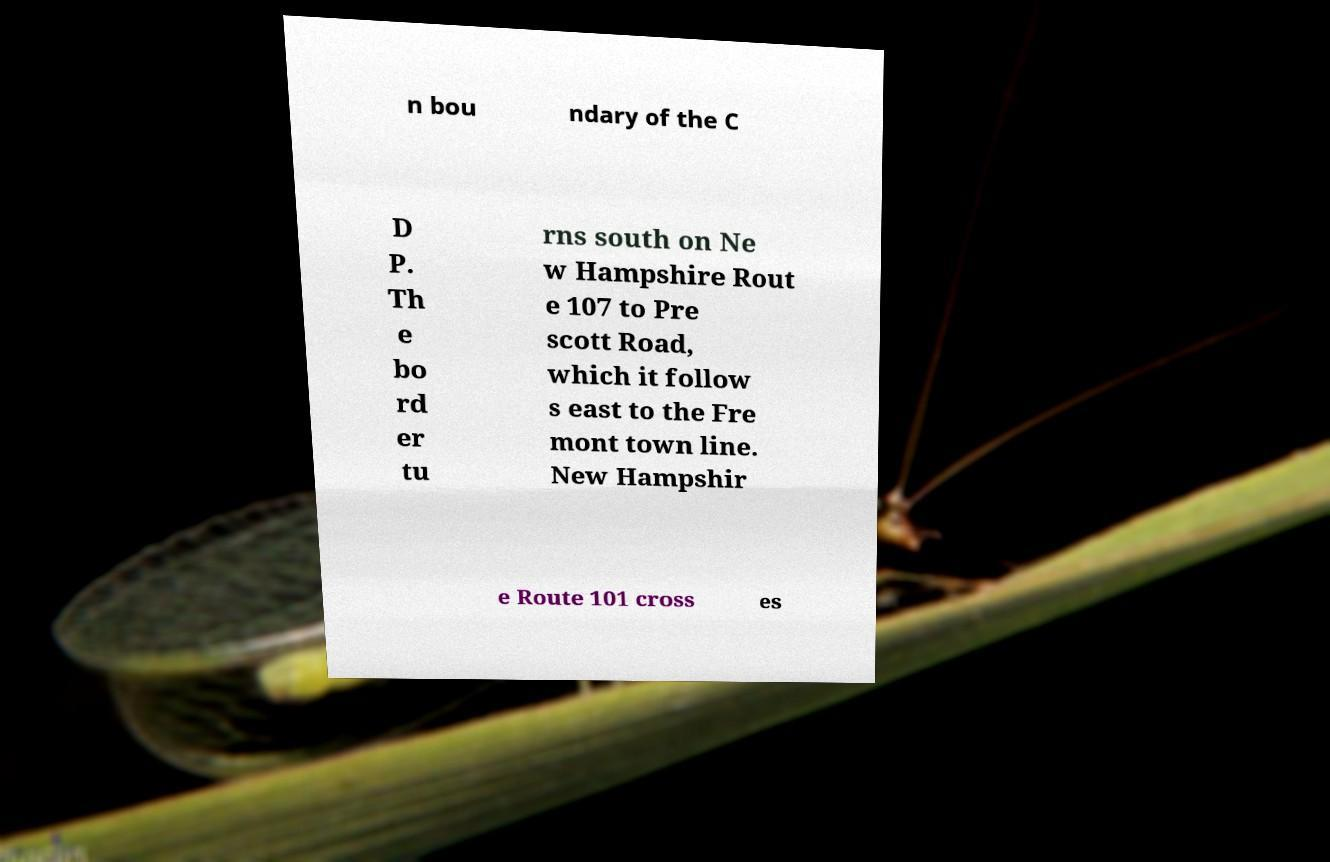Could you extract and type out the text from this image? n bou ndary of the C D P. Th e bo rd er tu rns south on Ne w Hampshire Rout e 107 to Pre scott Road, which it follow s east to the Fre mont town line. New Hampshir e Route 101 cross es 